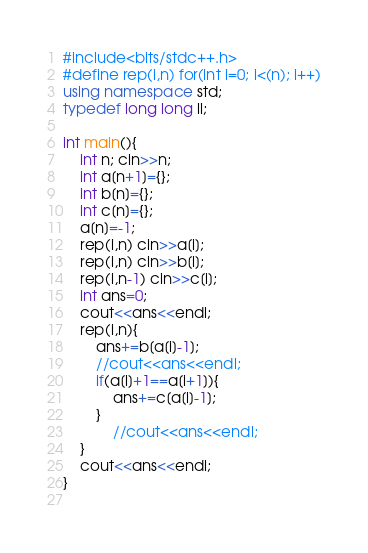Convert code to text. <code><loc_0><loc_0><loc_500><loc_500><_C++_>#include<bits/stdc++.h>
#define rep(i,n) for(int i=0; i<(n); i++)
using namespace std;
typedef long long ll;

int main(){
	int n; cin>>n;
	int a[n+1]={};
	int b[n]={};
	int c[n]={};
	a[n]=-1;
	rep(i,n) cin>>a[i];
	rep(i,n) cin>>b[i];
	rep(i,n-1) cin>>c[i];
	int ans=0;
	cout<<ans<<endl;
	rep(i,n){
		ans+=b[a[i]-1];
		//cout<<ans<<endl;
		if(a[i]+1==a[i+1]){
			ans+=c[a[i]-1];
		}
			//cout<<ans<<endl;
	}
	cout<<ans<<endl;
}
		</code> 